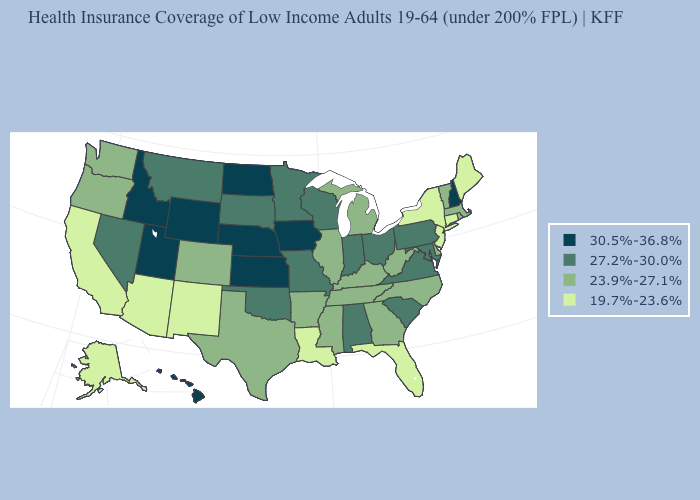Does Illinois have the lowest value in the MidWest?
Concise answer only. Yes. Is the legend a continuous bar?
Answer briefly. No. Does New Mexico have a lower value than California?
Keep it brief. No. What is the value of New Mexico?
Be succinct. 19.7%-23.6%. Which states hav the highest value in the South?
Short answer required. Alabama, Maryland, Oklahoma, South Carolina, Virginia. What is the highest value in states that border New Hampshire?
Quick response, please. 23.9%-27.1%. Does Oklahoma have the highest value in the South?
Give a very brief answer. Yes. Which states have the lowest value in the Northeast?
Be succinct. Connecticut, Maine, New Jersey, New York. Which states have the highest value in the USA?
Short answer required. Hawaii, Idaho, Iowa, Kansas, Nebraska, New Hampshire, North Dakota, Utah, Wyoming. What is the value of Maryland?
Concise answer only. 27.2%-30.0%. Name the states that have a value in the range 27.2%-30.0%?
Be succinct. Alabama, Indiana, Maryland, Minnesota, Missouri, Montana, Nevada, Ohio, Oklahoma, Pennsylvania, South Carolina, South Dakota, Virginia, Wisconsin. Does New York have a lower value than Connecticut?
Give a very brief answer. No. What is the lowest value in the USA?
Write a very short answer. 19.7%-23.6%. What is the lowest value in states that border Massachusetts?
Write a very short answer. 19.7%-23.6%. Does Mississippi have a lower value than New York?
Keep it brief. No. 